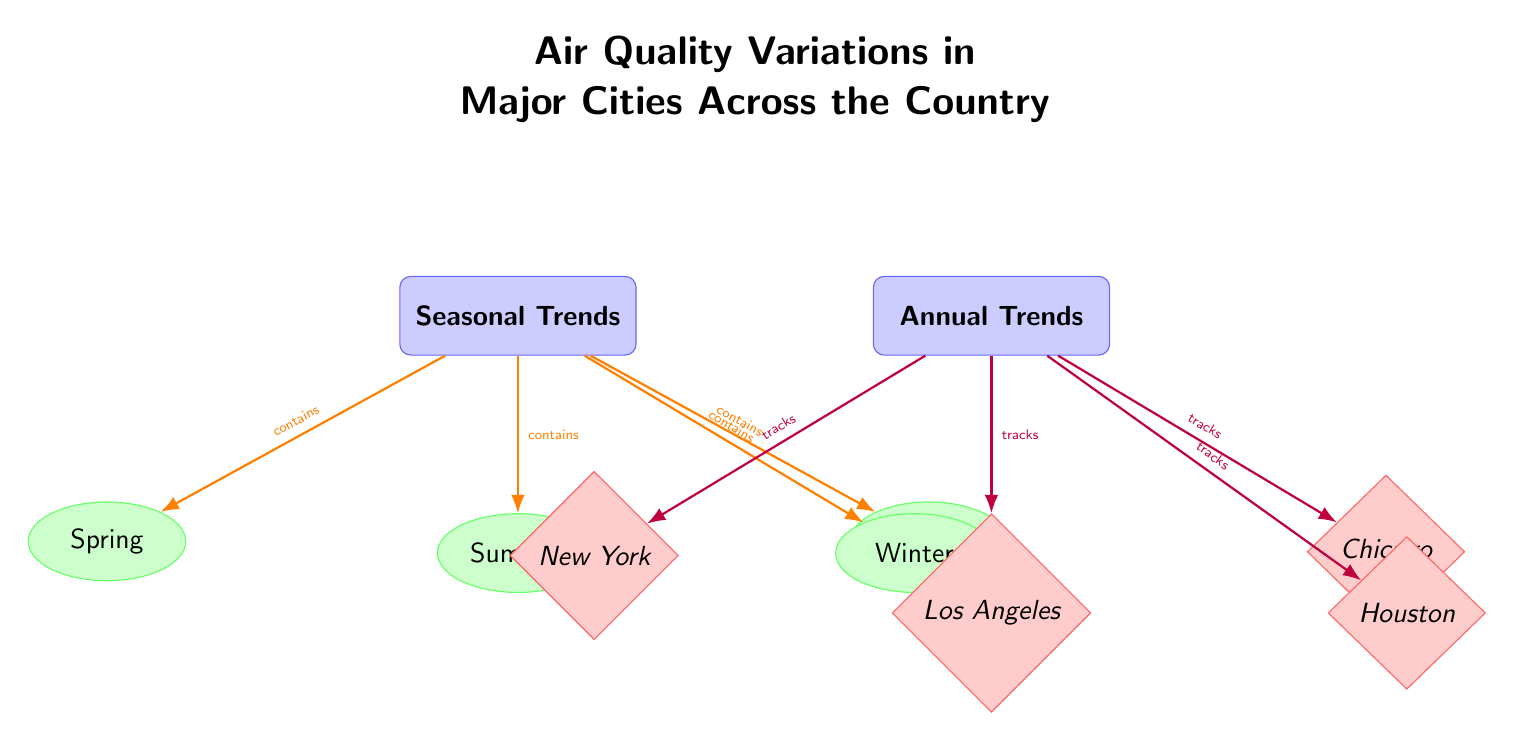What categories are represented in the diagram? The diagram includes two categories, "Seasonal Trends" and "Annual Trends," which can be identified at the top of the diagram.
Answer: Seasonal Trends, Annual Trends How many seasons are mentioned in the diagram? Counting the nodes under the "Seasonal Trends" category, there are four seasons: Spring, Summer, Fall, and Winter.
Answer: Four Which city is linked to the "Annual Trends" category? The diagram shows that "New York," "Los Angeles," "Chicago," and "Houston" are connected to the "Annual Trends" category.
Answer: New York, Los Angeles, Chicago, Houston What type of edges connect the seasonal trends to their category? The edges that connect the seasonal nodes (Spring, Summer, Fall, Winter) to the "Seasonal Trends" category are orange colored, indicating the relationship.
Answer: Orange Which season is located directly below the "Spring" season in the diagram? The diagram shows "Summer" directly below "Spring," indicating the arrangement of seasons visually.
Answer: Summer Which two colors are used for the nodes in the diagram? The categories use blue, the seasons use green, and the cities use red, making for distinct groups visually.
Answer: Blue, Green, Red What is the primary focus of the diagram's title? The title emphasizes "Air Quality Variations in Major Cities Across the Country," indicating the main topic covered by the diagram.
Answer: Air Quality Variations How are the cities categorized in the diagram? The cities are categorized as part of the "Annual Trends," and each city is represented as a diamond-shaped node linked to the annual trend category.
Answer: Annual Trends What relationship exists between seasons and air quality? The diagram connects seasonal trends categorically to their respective seasons, implying a relationship between air quality variations and the seasons.
Answer: Contains 